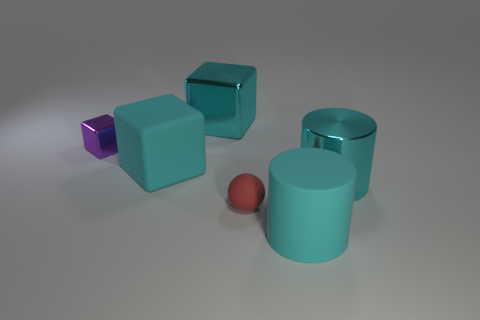Subtract all matte blocks. How many blocks are left? 2 Add 1 large cyan metallic things. How many objects exist? 7 Subtract all balls. How many objects are left? 5 Subtract all gray cylinders. How many cyan blocks are left? 2 Subtract all purple cubes. How many cubes are left? 2 Subtract 1 spheres. How many spheres are left? 0 Add 4 big shiny cylinders. How many big shiny cylinders exist? 5 Subtract 0 blue blocks. How many objects are left? 6 Subtract all gray blocks. Subtract all yellow cylinders. How many blocks are left? 3 Subtract all cyan cylinders. Subtract all purple shiny things. How many objects are left? 3 